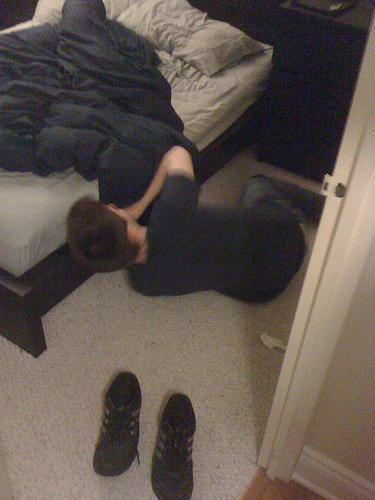How many shoes are there?
Give a very brief answer. 2. 